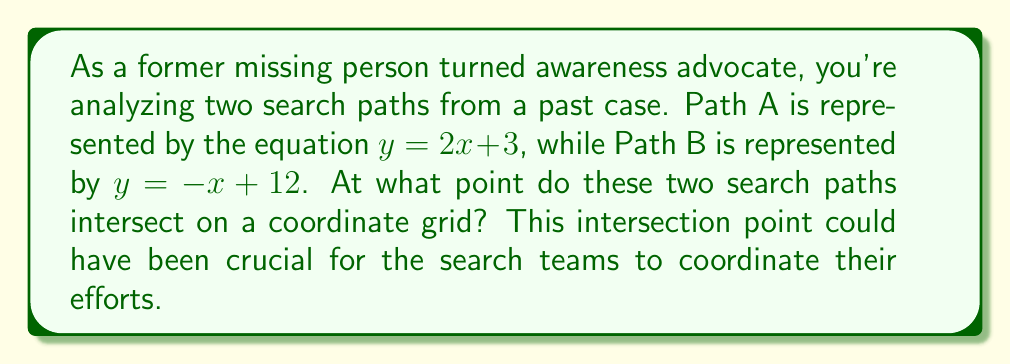Solve this math problem. To find the intersection point of the two search paths, we need to solve the system of equations:

$$\begin{cases}
y = 2x + 3 \\
y = -x + 12
\end{cases}$$

1) Since both equations are equal to $y$, we can set them equal to each other:

   $2x + 3 = -x + 12$

2) Add $x$ to both sides:

   $3x + 3 = 12$

3) Subtract 3 from both sides:

   $3x = 9$

4) Divide both sides by 3:

   $x = 3$

5) Now that we know $x = 3$, we can substitute this into either of the original equations to find $y$. Let's use the first equation:

   $y = 2x + 3$
   $y = 2(3) + 3$
   $y = 6 + 3$
   $y = 9$

6) Therefore, the intersection point is $(3, 9)$.

[asy]
import graph;
size(200);
xaxis("x", -1, 7, arrow=Arrow);
yaxis("y", -1, 13, arrow=Arrow);
draw((0,3)--(5,13), blue, arrow=Arrow);
draw((0,12)--(13,-1), red, arrow=Arrow);
dot((3,9));
label("(3, 9)", (3,9), NE);
label("Path A", (4,11), E, blue);
label("Path B", (6,6), SE, red);
[/asy]
Answer: The two search paths intersect at the point $(3, 9)$. 